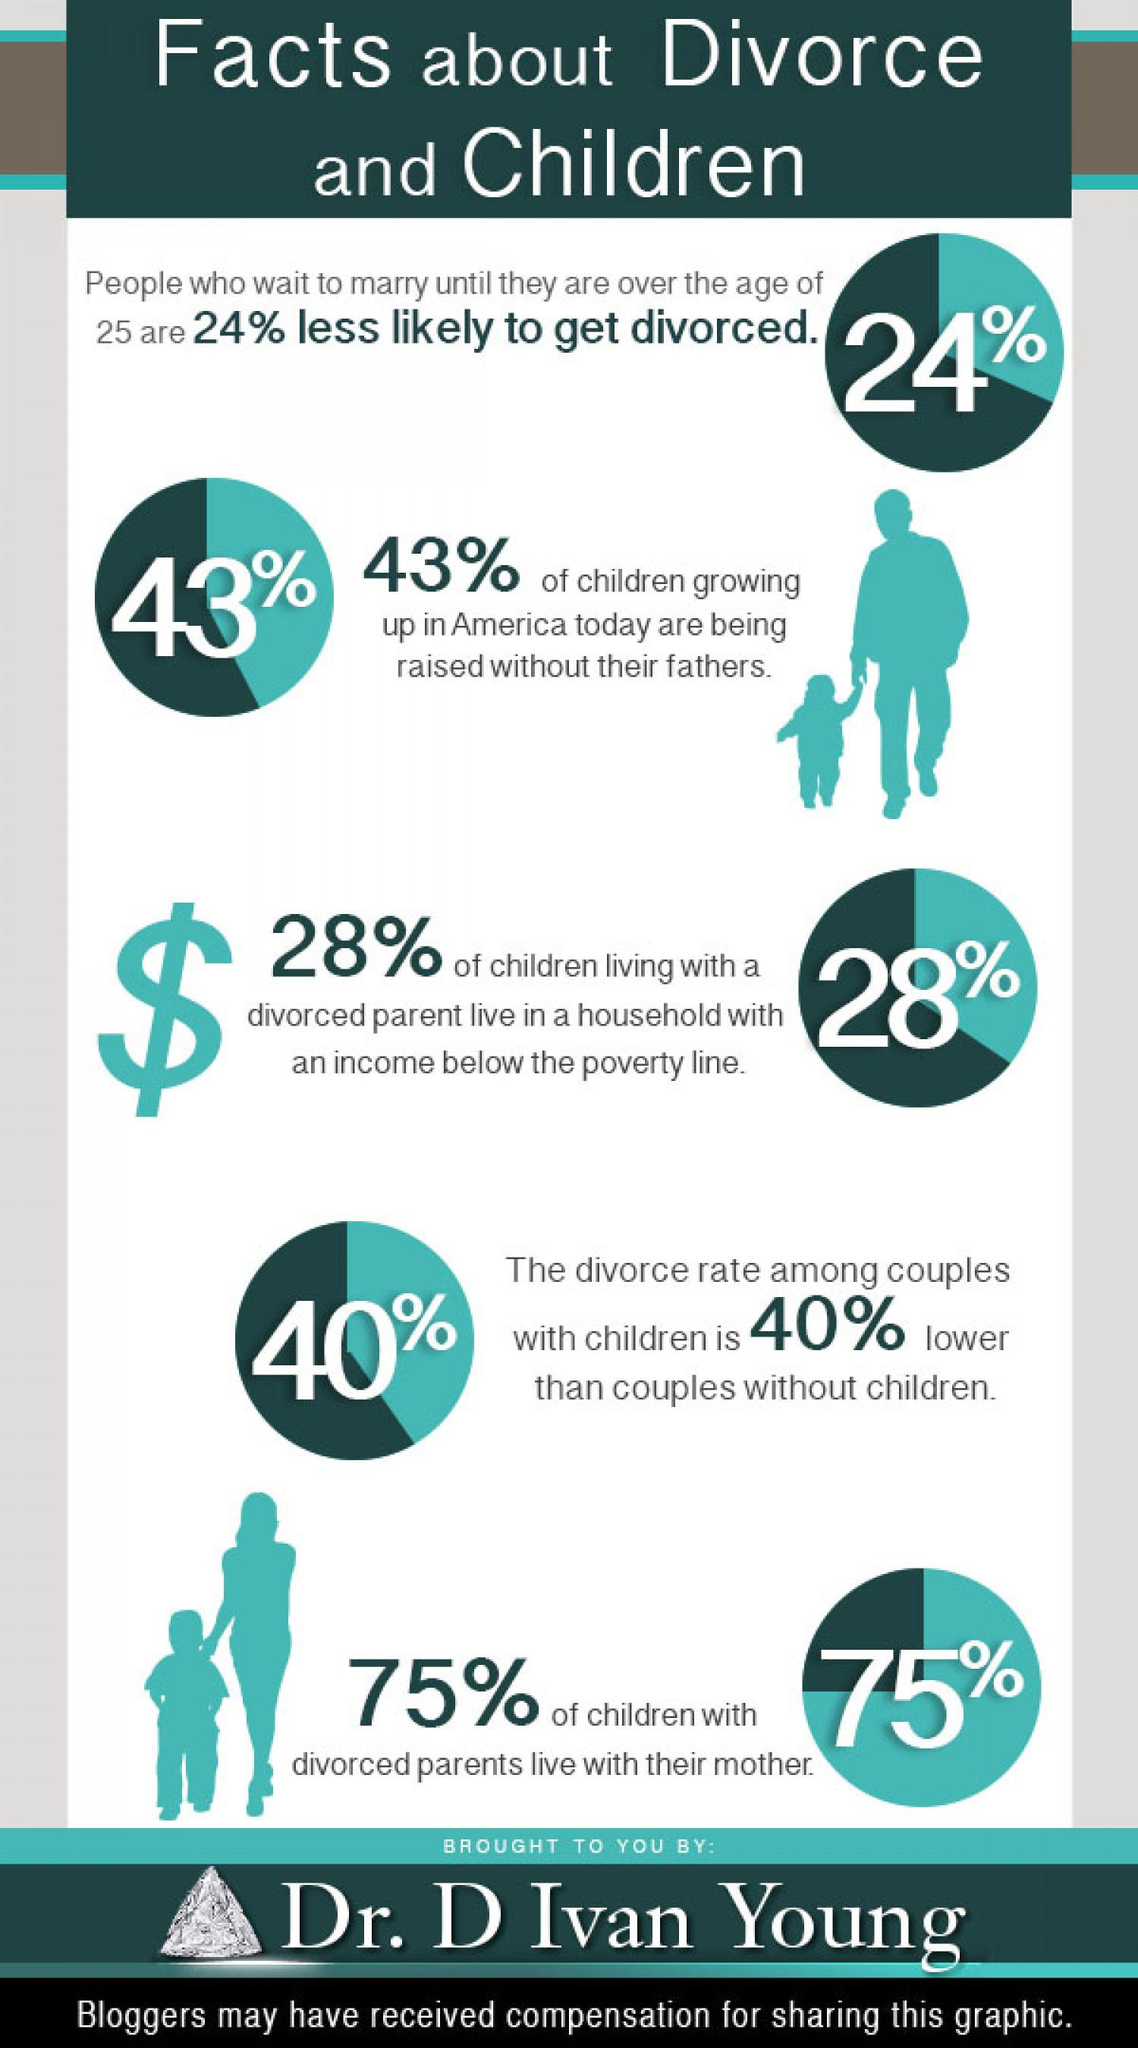Give some essential details in this illustration. Approximately 25% of children living with divorced parents do not live with their mother. According to recent data, 57% of children in America are raised with their fathers. According to recent data, a significant majority of children living with divorced parents, at 72%, are able to live above the poverty line. 